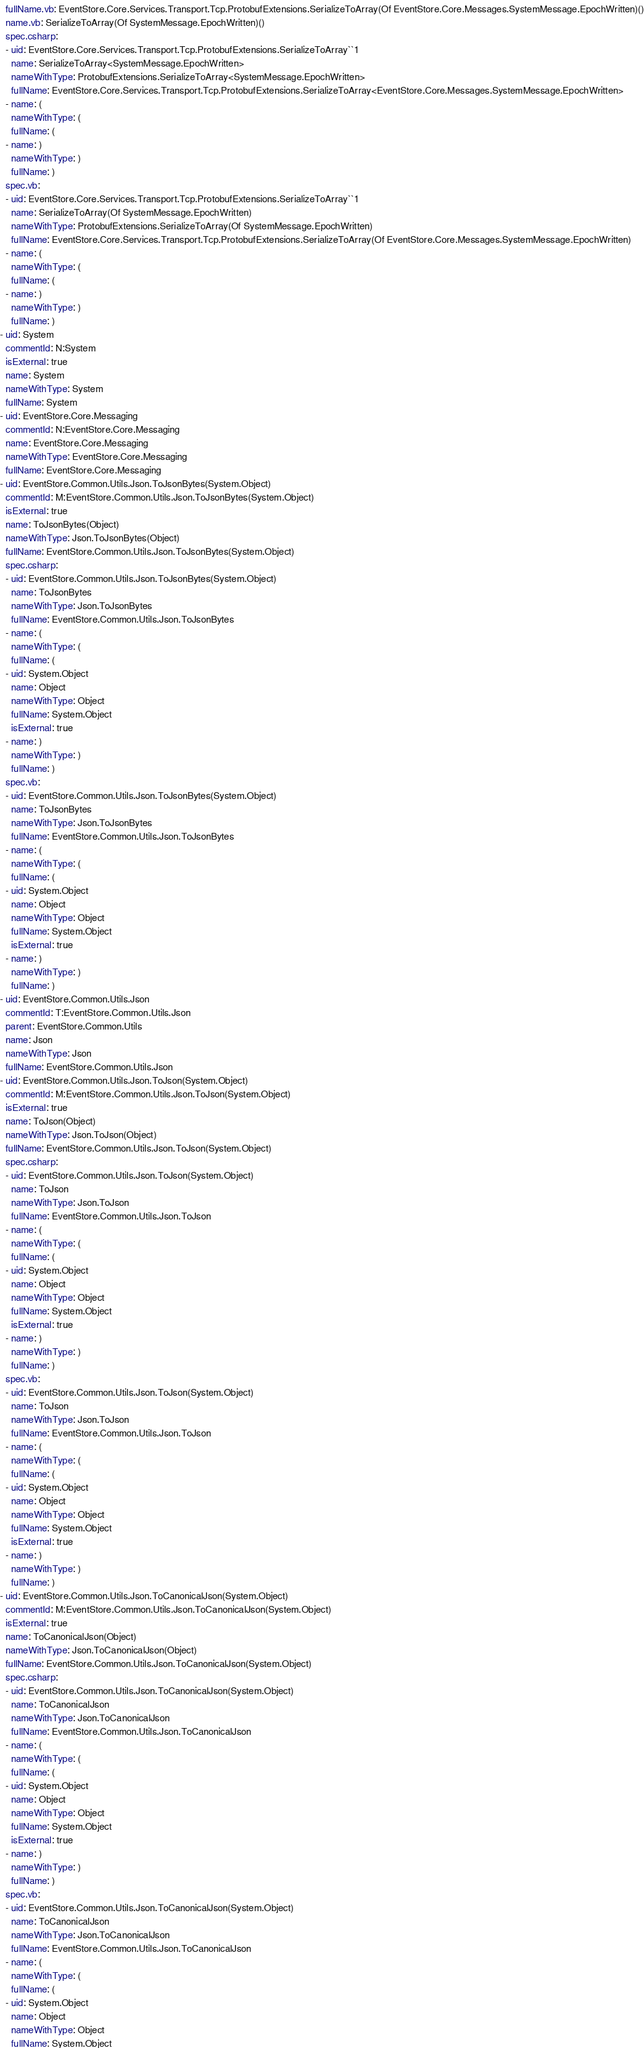<code> <loc_0><loc_0><loc_500><loc_500><_YAML_>  fullName.vb: EventStore.Core.Services.Transport.Tcp.ProtobufExtensions.SerializeToArray(Of EventStore.Core.Messages.SystemMessage.EpochWritten)()
  name.vb: SerializeToArray(Of SystemMessage.EpochWritten)()
  spec.csharp:
  - uid: EventStore.Core.Services.Transport.Tcp.ProtobufExtensions.SerializeToArray``1
    name: SerializeToArray<SystemMessage.EpochWritten>
    nameWithType: ProtobufExtensions.SerializeToArray<SystemMessage.EpochWritten>
    fullName: EventStore.Core.Services.Transport.Tcp.ProtobufExtensions.SerializeToArray<EventStore.Core.Messages.SystemMessage.EpochWritten>
  - name: (
    nameWithType: (
    fullName: (
  - name: )
    nameWithType: )
    fullName: )
  spec.vb:
  - uid: EventStore.Core.Services.Transport.Tcp.ProtobufExtensions.SerializeToArray``1
    name: SerializeToArray(Of SystemMessage.EpochWritten)
    nameWithType: ProtobufExtensions.SerializeToArray(Of SystemMessage.EpochWritten)
    fullName: EventStore.Core.Services.Transport.Tcp.ProtobufExtensions.SerializeToArray(Of EventStore.Core.Messages.SystemMessage.EpochWritten)
  - name: (
    nameWithType: (
    fullName: (
  - name: )
    nameWithType: )
    fullName: )
- uid: System
  commentId: N:System
  isExternal: true
  name: System
  nameWithType: System
  fullName: System
- uid: EventStore.Core.Messaging
  commentId: N:EventStore.Core.Messaging
  name: EventStore.Core.Messaging
  nameWithType: EventStore.Core.Messaging
  fullName: EventStore.Core.Messaging
- uid: EventStore.Common.Utils.Json.ToJsonBytes(System.Object)
  commentId: M:EventStore.Common.Utils.Json.ToJsonBytes(System.Object)
  isExternal: true
  name: ToJsonBytes(Object)
  nameWithType: Json.ToJsonBytes(Object)
  fullName: EventStore.Common.Utils.Json.ToJsonBytes(System.Object)
  spec.csharp:
  - uid: EventStore.Common.Utils.Json.ToJsonBytes(System.Object)
    name: ToJsonBytes
    nameWithType: Json.ToJsonBytes
    fullName: EventStore.Common.Utils.Json.ToJsonBytes
  - name: (
    nameWithType: (
    fullName: (
  - uid: System.Object
    name: Object
    nameWithType: Object
    fullName: System.Object
    isExternal: true
  - name: )
    nameWithType: )
    fullName: )
  spec.vb:
  - uid: EventStore.Common.Utils.Json.ToJsonBytes(System.Object)
    name: ToJsonBytes
    nameWithType: Json.ToJsonBytes
    fullName: EventStore.Common.Utils.Json.ToJsonBytes
  - name: (
    nameWithType: (
    fullName: (
  - uid: System.Object
    name: Object
    nameWithType: Object
    fullName: System.Object
    isExternal: true
  - name: )
    nameWithType: )
    fullName: )
- uid: EventStore.Common.Utils.Json
  commentId: T:EventStore.Common.Utils.Json
  parent: EventStore.Common.Utils
  name: Json
  nameWithType: Json
  fullName: EventStore.Common.Utils.Json
- uid: EventStore.Common.Utils.Json.ToJson(System.Object)
  commentId: M:EventStore.Common.Utils.Json.ToJson(System.Object)
  isExternal: true
  name: ToJson(Object)
  nameWithType: Json.ToJson(Object)
  fullName: EventStore.Common.Utils.Json.ToJson(System.Object)
  spec.csharp:
  - uid: EventStore.Common.Utils.Json.ToJson(System.Object)
    name: ToJson
    nameWithType: Json.ToJson
    fullName: EventStore.Common.Utils.Json.ToJson
  - name: (
    nameWithType: (
    fullName: (
  - uid: System.Object
    name: Object
    nameWithType: Object
    fullName: System.Object
    isExternal: true
  - name: )
    nameWithType: )
    fullName: )
  spec.vb:
  - uid: EventStore.Common.Utils.Json.ToJson(System.Object)
    name: ToJson
    nameWithType: Json.ToJson
    fullName: EventStore.Common.Utils.Json.ToJson
  - name: (
    nameWithType: (
    fullName: (
  - uid: System.Object
    name: Object
    nameWithType: Object
    fullName: System.Object
    isExternal: true
  - name: )
    nameWithType: )
    fullName: )
- uid: EventStore.Common.Utils.Json.ToCanonicalJson(System.Object)
  commentId: M:EventStore.Common.Utils.Json.ToCanonicalJson(System.Object)
  isExternal: true
  name: ToCanonicalJson(Object)
  nameWithType: Json.ToCanonicalJson(Object)
  fullName: EventStore.Common.Utils.Json.ToCanonicalJson(System.Object)
  spec.csharp:
  - uid: EventStore.Common.Utils.Json.ToCanonicalJson(System.Object)
    name: ToCanonicalJson
    nameWithType: Json.ToCanonicalJson
    fullName: EventStore.Common.Utils.Json.ToCanonicalJson
  - name: (
    nameWithType: (
    fullName: (
  - uid: System.Object
    name: Object
    nameWithType: Object
    fullName: System.Object
    isExternal: true
  - name: )
    nameWithType: )
    fullName: )
  spec.vb:
  - uid: EventStore.Common.Utils.Json.ToCanonicalJson(System.Object)
    name: ToCanonicalJson
    nameWithType: Json.ToCanonicalJson
    fullName: EventStore.Common.Utils.Json.ToCanonicalJson
  - name: (
    nameWithType: (
    fullName: (
  - uid: System.Object
    name: Object
    nameWithType: Object
    fullName: System.Object</code> 